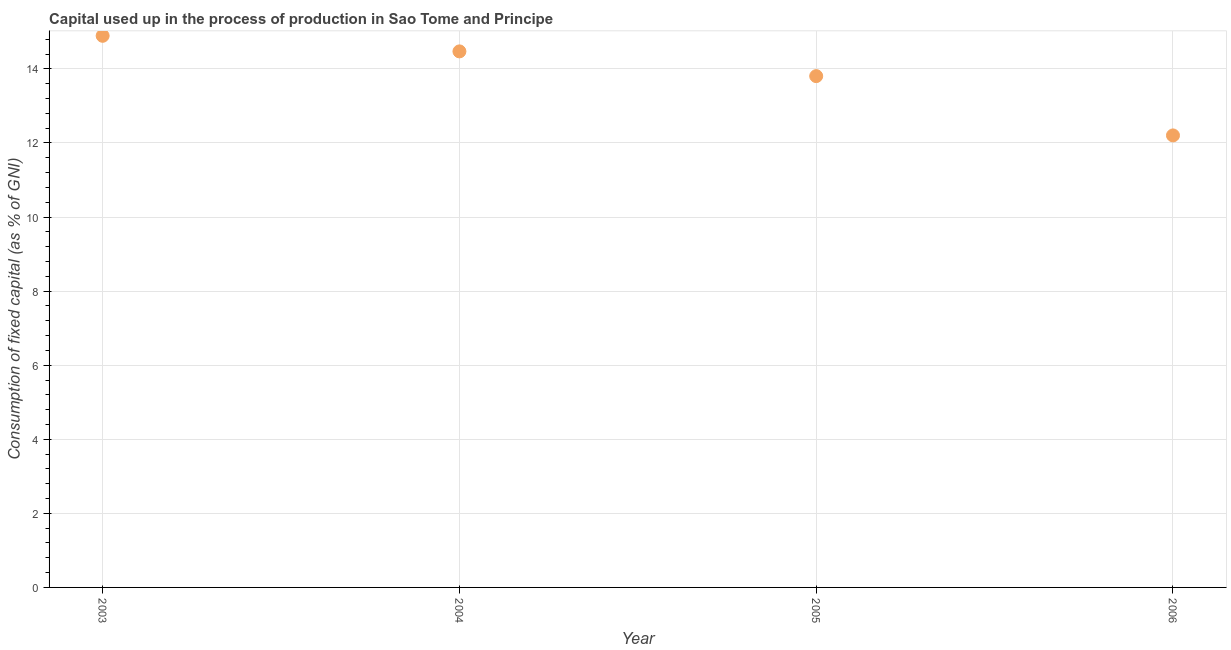What is the consumption of fixed capital in 2005?
Give a very brief answer. 13.8. Across all years, what is the maximum consumption of fixed capital?
Provide a succinct answer. 14.89. Across all years, what is the minimum consumption of fixed capital?
Your answer should be compact. 12.2. In which year was the consumption of fixed capital maximum?
Make the answer very short. 2003. In which year was the consumption of fixed capital minimum?
Your response must be concise. 2006. What is the sum of the consumption of fixed capital?
Provide a short and direct response. 55.37. What is the difference between the consumption of fixed capital in 2004 and 2006?
Give a very brief answer. 2.27. What is the average consumption of fixed capital per year?
Provide a succinct answer. 13.84. What is the median consumption of fixed capital?
Give a very brief answer. 14.14. In how many years, is the consumption of fixed capital greater than 1.6 %?
Your answer should be very brief. 4. Do a majority of the years between 2003 and 2004 (inclusive) have consumption of fixed capital greater than 6 %?
Your response must be concise. Yes. What is the ratio of the consumption of fixed capital in 2005 to that in 2006?
Your answer should be compact. 1.13. Is the consumption of fixed capital in 2004 less than that in 2005?
Your answer should be compact. No. Is the difference between the consumption of fixed capital in 2003 and 2004 greater than the difference between any two years?
Your response must be concise. No. What is the difference between the highest and the second highest consumption of fixed capital?
Your response must be concise. 0.42. Is the sum of the consumption of fixed capital in 2003 and 2005 greater than the maximum consumption of fixed capital across all years?
Provide a short and direct response. Yes. What is the difference between the highest and the lowest consumption of fixed capital?
Make the answer very short. 2.69. Are the values on the major ticks of Y-axis written in scientific E-notation?
Make the answer very short. No. What is the title of the graph?
Offer a terse response. Capital used up in the process of production in Sao Tome and Principe. What is the label or title of the X-axis?
Your answer should be compact. Year. What is the label or title of the Y-axis?
Your answer should be very brief. Consumption of fixed capital (as % of GNI). What is the Consumption of fixed capital (as % of GNI) in 2003?
Keep it short and to the point. 14.89. What is the Consumption of fixed capital (as % of GNI) in 2004?
Your answer should be compact. 14.47. What is the Consumption of fixed capital (as % of GNI) in 2005?
Offer a very short reply. 13.8. What is the Consumption of fixed capital (as % of GNI) in 2006?
Make the answer very short. 12.2. What is the difference between the Consumption of fixed capital (as % of GNI) in 2003 and 2004?
Ensure brevity in your answer.  0.42. What is the difference between the Consumption of fixed capital (as % of GNI) in 2003 and 2005?
Provide a short and direct response. 1.09. What is the difference between the Consumption of fixed capital (as % of GNI) in 2003 and 2006?
Offer a very short reply. 2.69. What is the difference between the Consumption of fixed capital (as % of GNI) in 2004 and 2005?
Offer a very short reply. 0.67. What is the difference between the Consumption of fixed capital (as % of GNI) in 2004 and 2006?
Provide a succinct answer. 2.27. What is the difference between the Consumption of fixed capital (as % of GNI) in 2005 and 2006?
Offer a terse response. 1.6. What is the ratio of the Consumption of fixed capital (as % of GNI) in 2003 to that in 2004?
Offer a very short reply. 1.03. What is the ratio of the Consumption of fixed capital (as % of GNI) in 2003 to that in 2005?
Your answer should be very brief. 1.08. What is the ratio of the Consumption of fixed capital (as % of GNI) in 2003 to that in 2006?
Your response must be concise. 1.22. What is the ratio of the Consumption of fixed capital (as % of GNI) in 2004 to that in 2005?
Your answer should be very brief. 1.05. What is the ratio of the Consumption of fixed capital (as % of GNI) in 2004 to that in 2006?
Ensure brevity in your answer.  1.19. What is the ratio of the Consumption of fixed capital (as % of GNI) in 2005 to that in 2006?
Offer a very short reply. 1.13. 